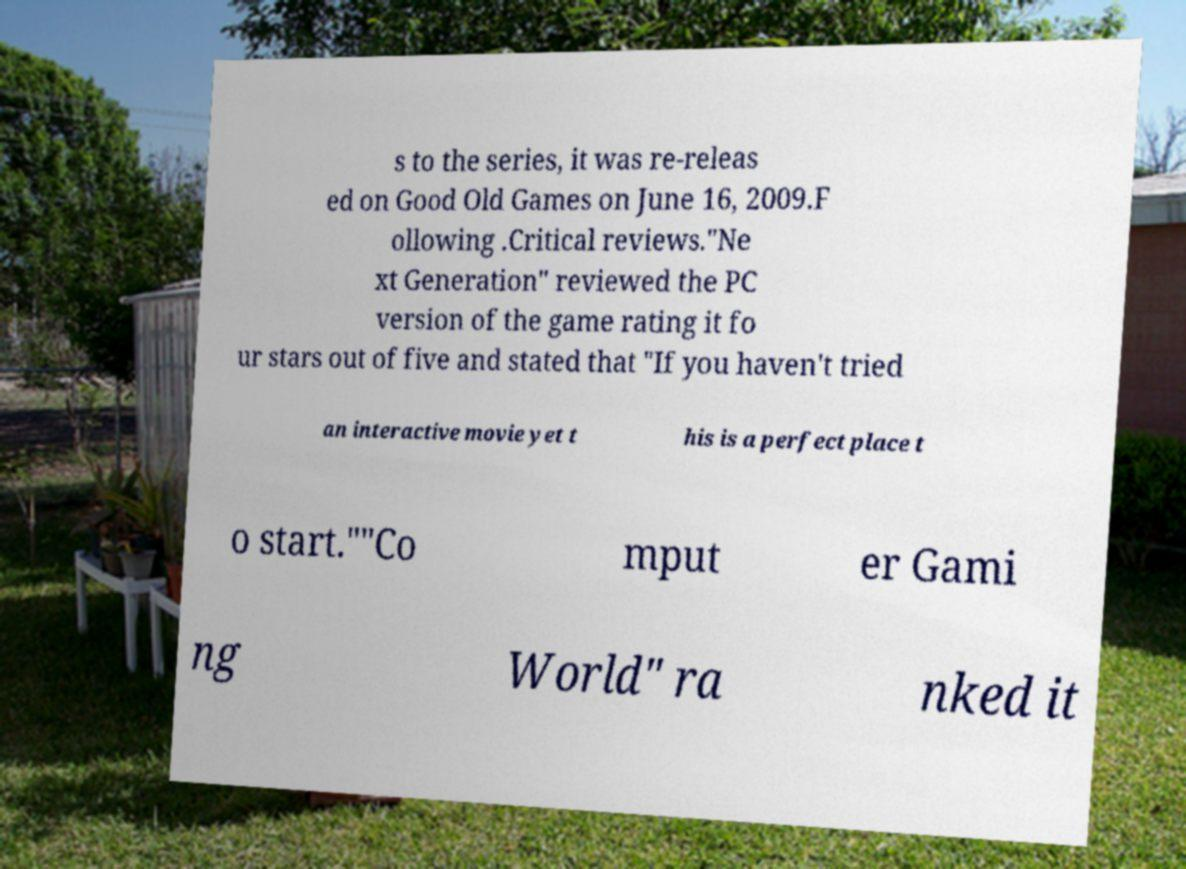For documentation purposes, I need the text within this image transcribed. Could you provide that? s to the series, it was re-releas ed on Good Old Games on June 16, 2009.F ollowing .Critical reviews."Ne xt Generation" reviewed the PC version of the game rating it fo ur stars out of five and stated that "If you haven't tried an interactive movie yet t his is a perfect place t o start.""Co mput er Gami ng World" ra nked it 